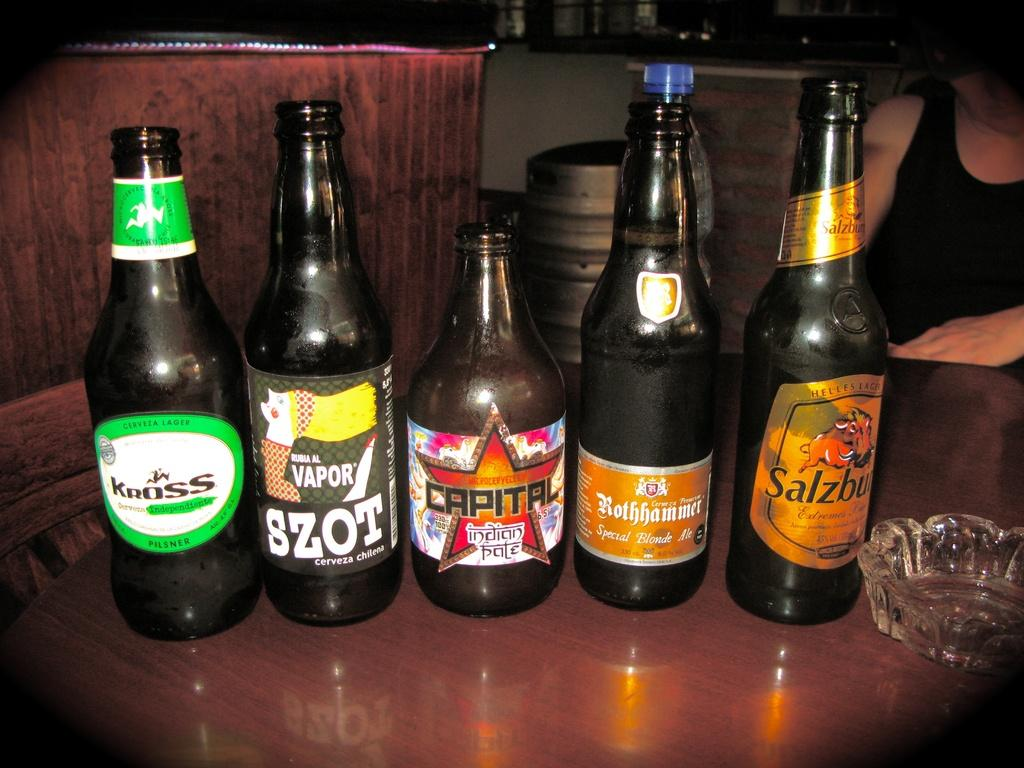<image>
Provide a brief description of the given image. Several beer bottles including Kross and Capital beers are on a table by an ash tray. 